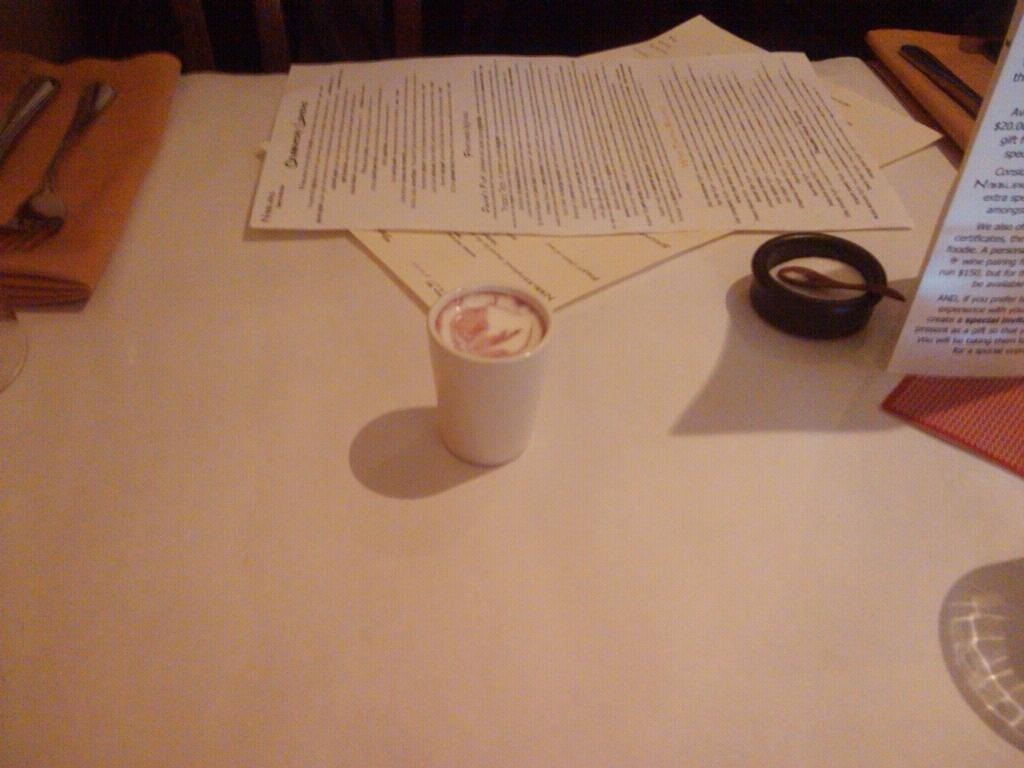What objects can be seen in the image related to writing or reading? There are papers in the image. What objects can be seen in the image related to eating or drinking? There is a glass, a fork, a spoon, a napkin, a bowl with a spoon, and the bowl and spoon are on a table. Where is the lake located in the image? There is no lake present in the image. What type of substance is being taught in the class in the image? There is no class or substance being taught in the image. 